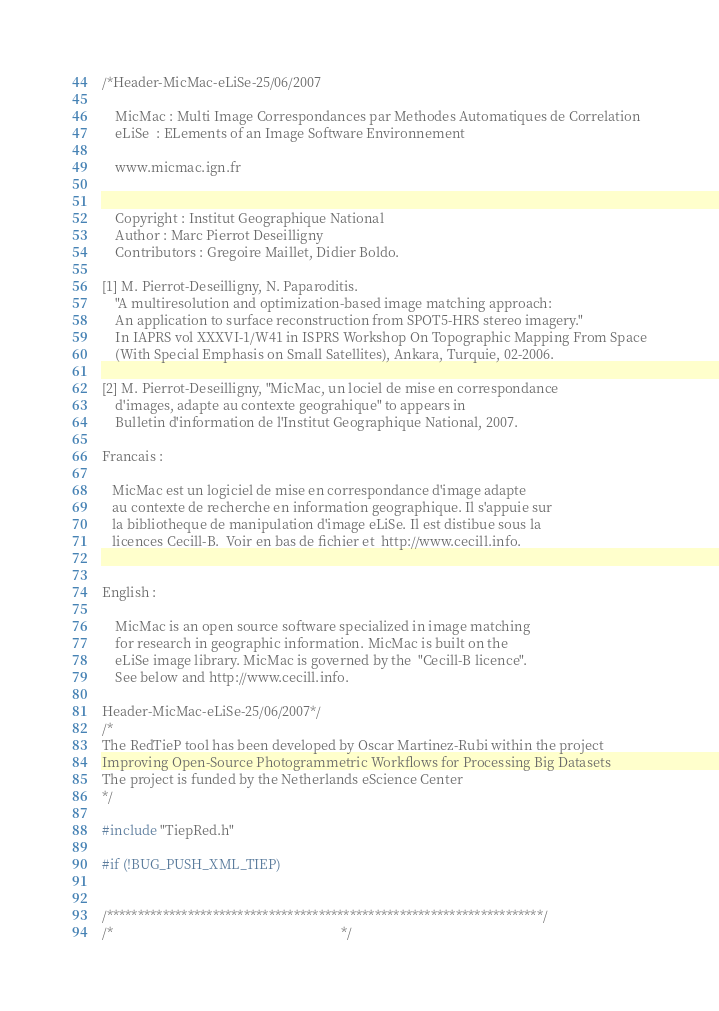Convert code to text. <code><loc_0><loc_0><loc_500><loc_500><_C++_>/*Header-MicMac-eLiSe-25/06/2007

    MicMac : Multi Image Correspondances par Methodes Automatiques de Correlation
    eLiSe  : ELements of an Image Software Environnement

    www.micmac.ign.fr


    Copyright : Institut Geographique National
    Author : Marc Pierrot Deseilligny
    Contributors : Gregoire Maillet, Didier Boldo.

[1] M. Pierrot-Deseilligny, N. Paparoditis.
    "A multiresolution and optimization-based image matching approach:
    An application to surface reconstruction from SPOT5-HRS stereo imagery."
    In IAPRS vol XXXVI-1/W41 in ISPRS Workshop On Topographic Mapping From Space
    (With Special Emphasis on Small Satellites), Ankara, Turquie, 02-2006.

[2] M. Pierrot-Deseilligny, "MicMac, un lociel de mise en correspondance
    d'images, adapte au contexte geograhique" to appears in
    Bulletin d'information de l'Institut Geographique National, 2007.

Francais :

   MicMac est un logiciel de mise en correspondance d'image adapte
   au contexte de recherche en information geographique. Il s'appuie sur
   la bibliotheque de manipulation d'image eLiSe. Il est distibue sous la
   licences Cecill-B.  Voir en bas de fichier et  http://www.cecill.info.


English :

    MicMac is an open source software specialized in image matching
    for research in geographic information. MicMac is built on the
    eLiSe image library. MicMac is governed by the  "Cecill-B licence".
    See below and http://www.cecill.info.

Header-MicMac-eLiSe-25/06/2007*/
/*
The RedTieP tool has been developed by Oscar Martinez-Rubi within the project
Improving Open-Source Photogrammetric Workflows for Processing Big Datasets
The project is funded by the Netherlands eScience Center
*/

#include "TiepRed.h"

#if (!BUG_PUSH_XML_TIEP)


/**********************************************************************/
/*                                                                    */</code> 